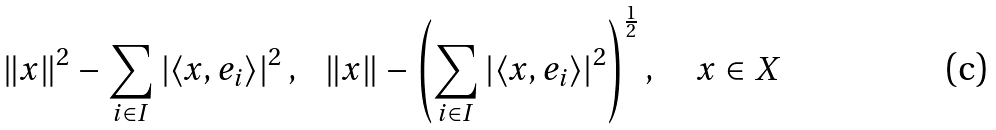Convert formula to latex. <formula><loc_0><loc_0><loc_500><loc_500>\left \| x \right \| ^ { 2 } - \sum _ { i \in I } \left | \left \langle x , e _ { i } \right \rangle \right | ^ { 2 } , \text { \ } \left \| x \right \| - \left ( \sum _ { i \in I } \left | \left \langle x , e _ { i } \right \rangle \right | ^ { 2 } \right ) ^ { \frac { 1 } { 2 } } , \quad x \in X</formula> 